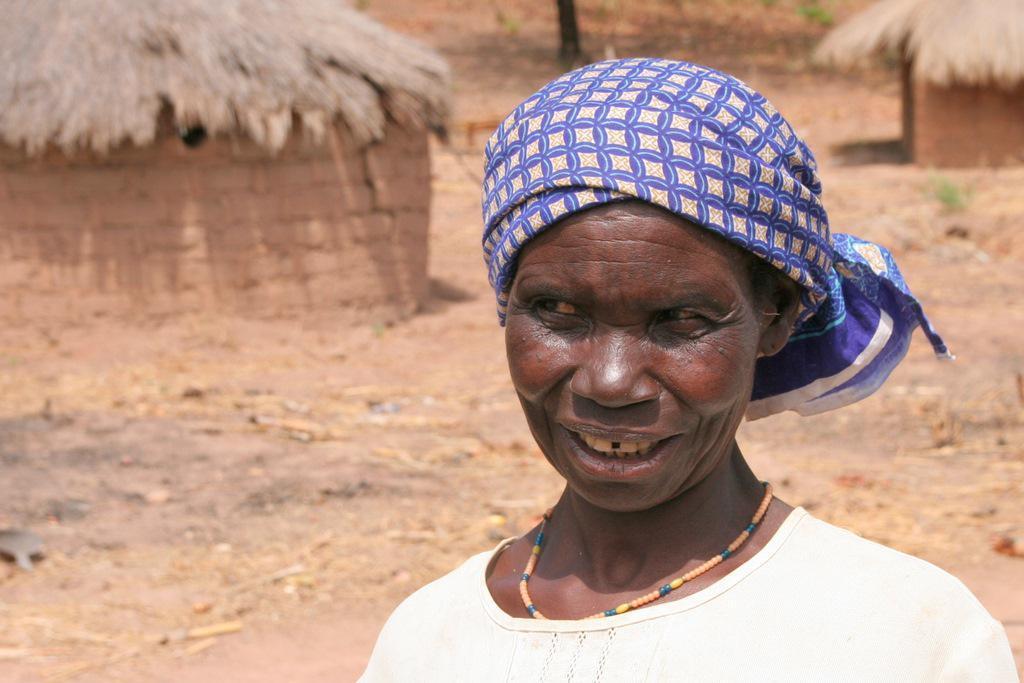Can you describe this image briefly? In this image there are huts towards left side and right side. There is a women standing in the foreground with a white color shirt and blue color stole with a neck piece. There are small plants in the background 